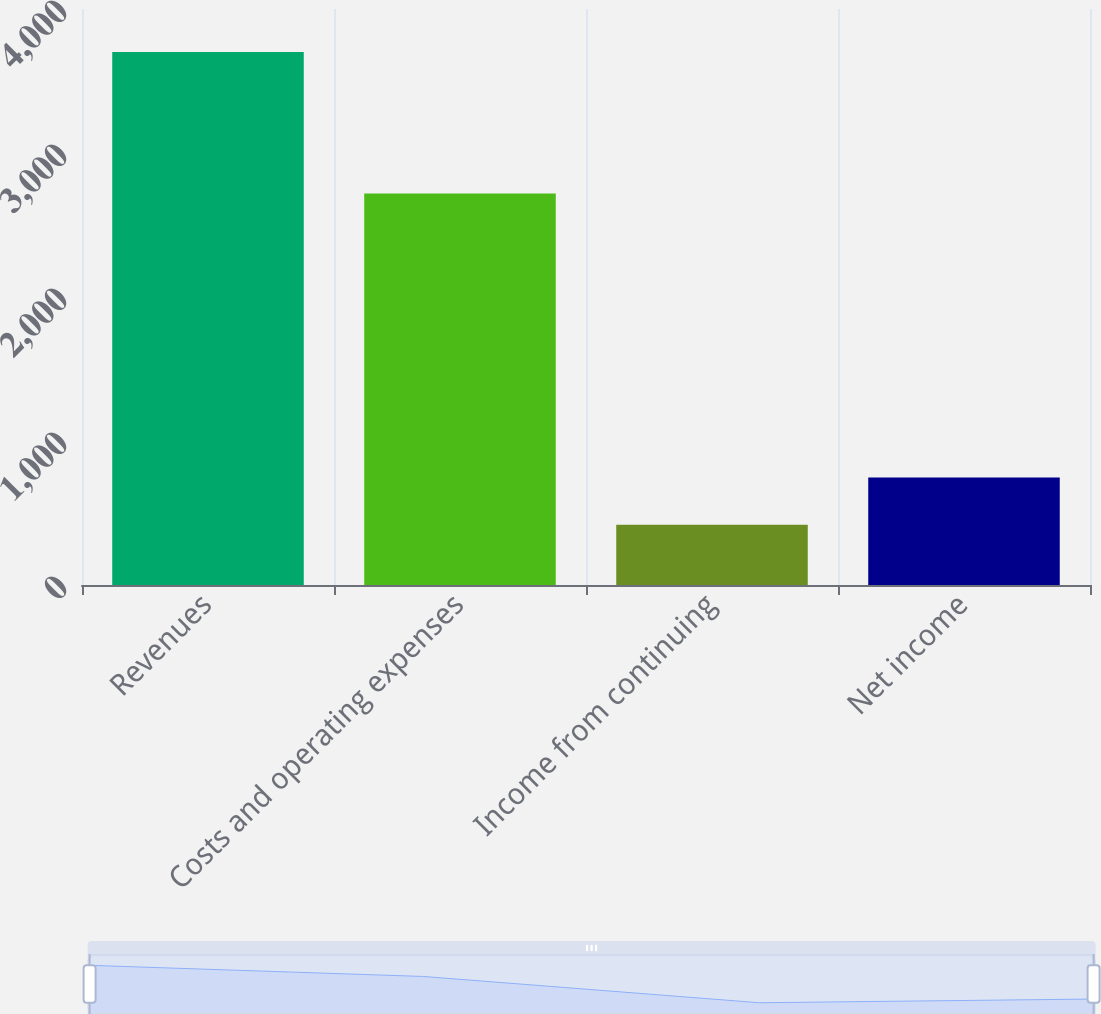Convert chart to OTSL. <chart><loc_0><loc_0><loc_500><loc_500><bar_chart><fcel>Revenues<fcel>Costs and operating expenses<fcel>Income from continuing<fcel>Net income<nl><fcel>3701<fcel>2719<fcel>419<fcel>747.2<nl></chart> 